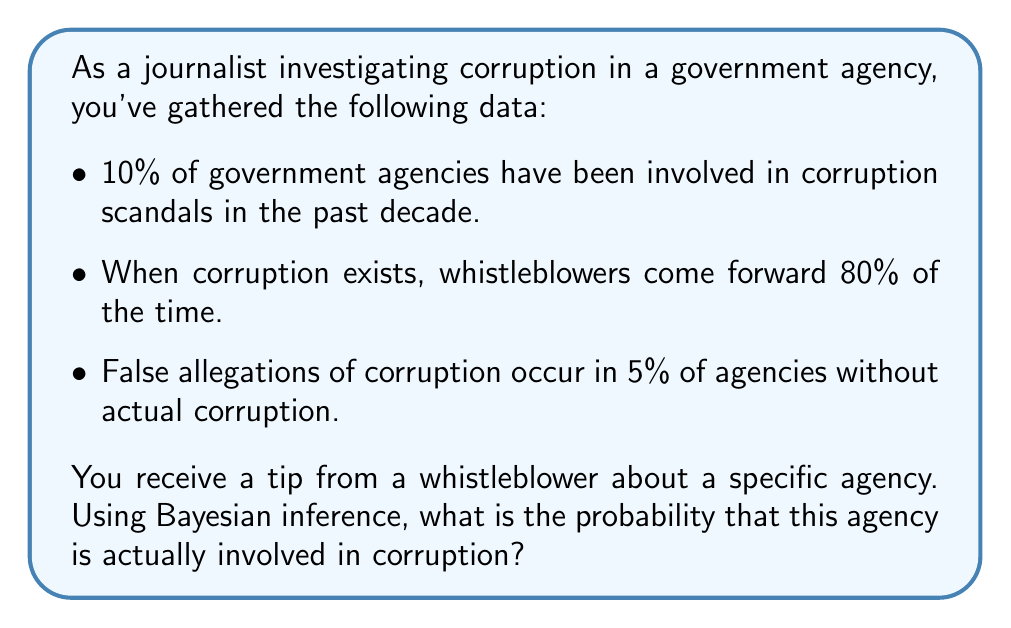Can you solve this math problem? Let's approach this step-by-step using Bayes' theorem:

1) Define our events:
   A: The agency is corrupt
   B: A whistleblower comes forward

2) Given probabilities:
   P(A) = 0.10 (prior probability of corruption)
   P(B|A) = 0.80 (probability of a whistleblower given corruption)
   P(B|not A) = 0.05 (probability of a false allegation)

3) We want to find P(A|B) using Bayes' theorem:

   $$P(A|B) = \frac{P(B|A) \cdot P(A)}{P(B)}$$

4) We need to calculate P(B):
   P(B) = P(B|A) · P(A) + P(B|not A) · P(not A)
        = 0.80 · 0.10 + 0.05 · 0.90
        = 0.08 + 0.045
        = 0.125

5) Now we can apply Bayes' theorem:

   $$P(A|B) = \frac{0.80 \cdot 0.10}{0.125} = \frac{0.08}{0.125} = 0.64$$

6) Convert to a percentage: 0.64 * 100 = 64%

Therefore, given a whistleblower's tip, there is a 64% probability that the agency is actually involved in corruption.
Answer: 64% 